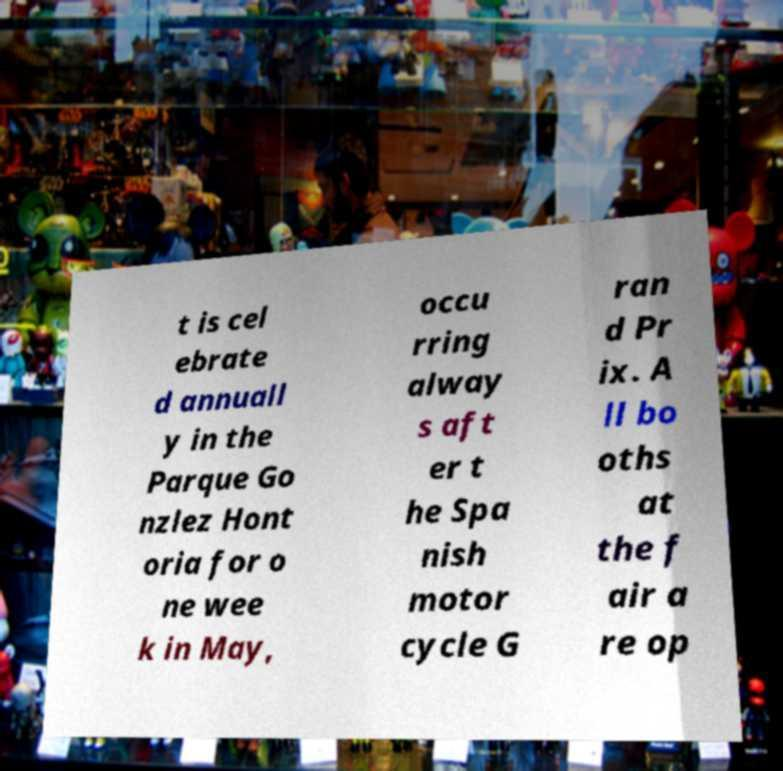There's text embedded in this image that I need extracted. Can you transcribe it verbatim? t is cel ebrate d annuall y in the Parque Go nzlez Hont oria for o ne wee k in May, occu rring alway s aft er t he Spa nish motor cycle G ran d Pr ix. A ll bo oths at the f air a re op 